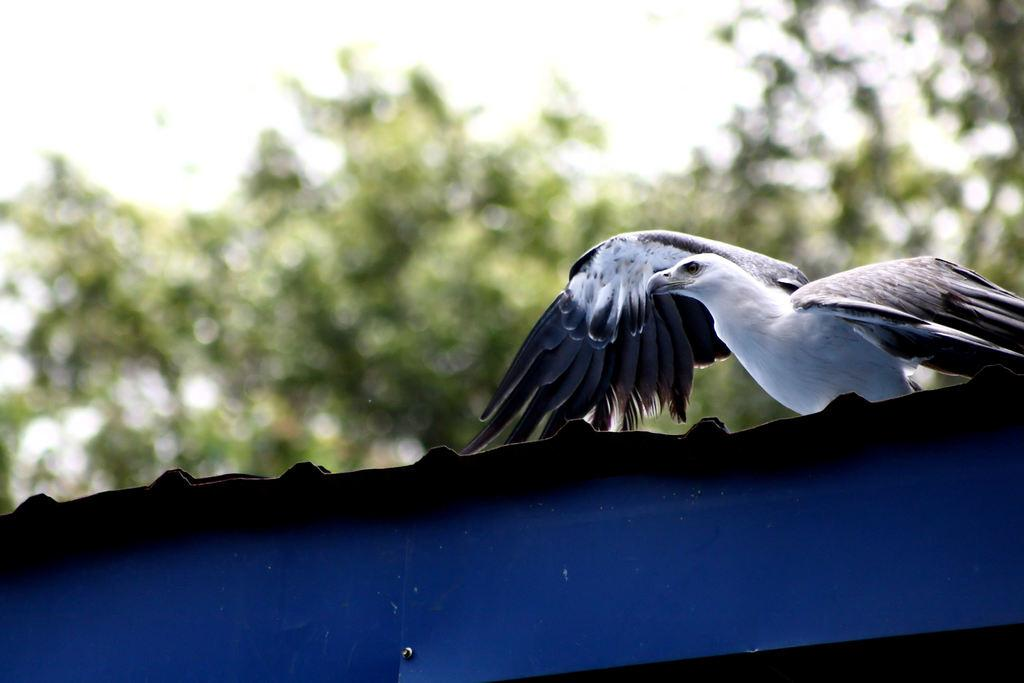What type of animal is in the image? There is a bird in the image. What colors can be seen on the bird? The bird is white and black in color. Where is the bird sitting? The bird is sitting on a shed. What color is the shed? The shed is blue in color. What can be seen in the background of the image? There are trees in the background of the image. What is visible at the top of the image? The sky is visible at the top of the image. What type of camera is the bird using to take pictures in the image? There is no camera present in the image, and the bird is not taking pictures. 